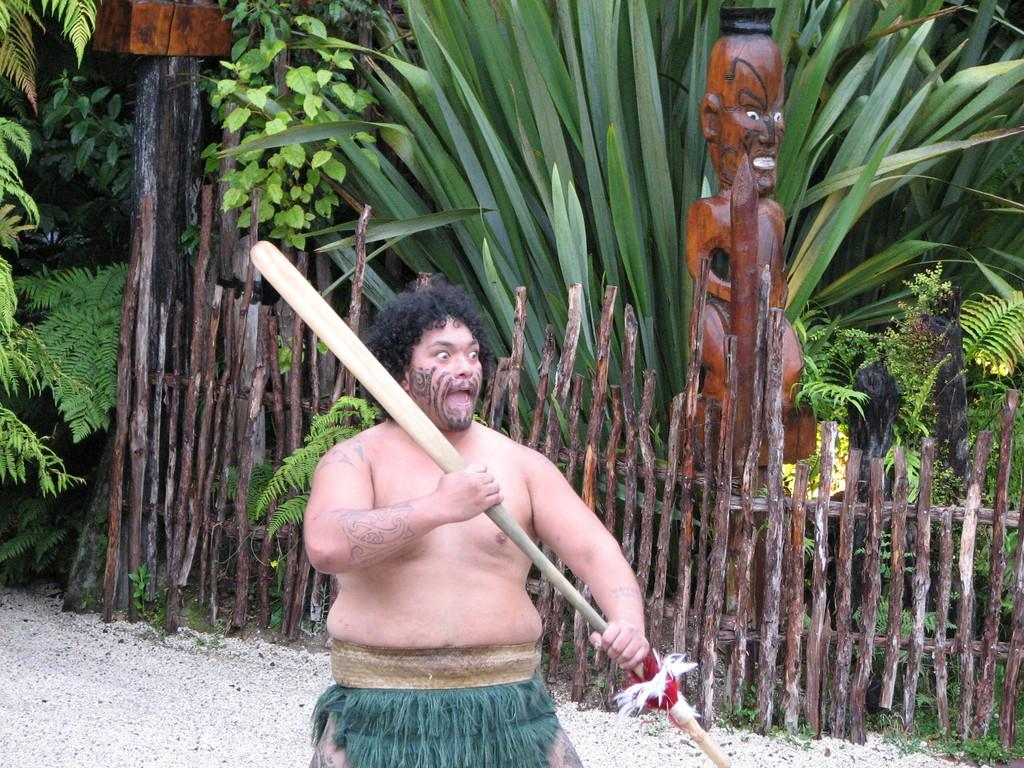What can be seen in the image? There is a person in the image. What is the person doing in the image? The person is holding an object. What can be seen in the background of the image? There are wooden objects, trees, plants, and other objects in the background of the image. What type of ink is being used by the person in the image? There is no ink present in the image, as the person is holding an object rather than writing or drawing. 